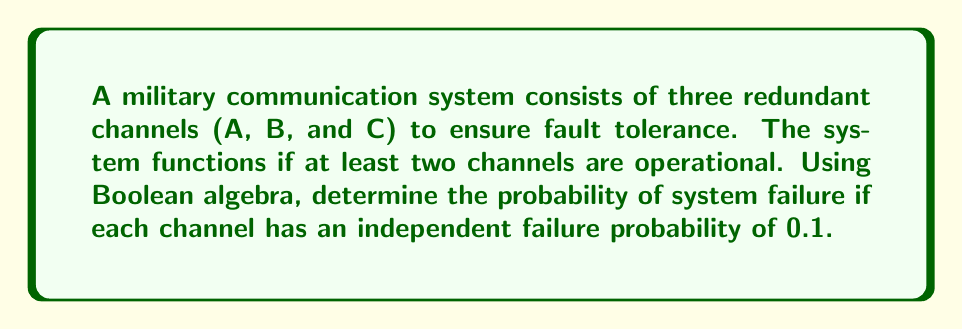Could you help me with this problem? Let's approach this step-by-step using Boolean algebra and probability theory:

1) First, let's define our variables:
   Let A, B, and C represent the event that each channel is operational.

2) The system fails if two or more channels fail. We can express this as:
   System Failure = $\overline{A}\overline{B}\overline{C} + \overline{A}\overline{B}C + \overline{A}B\overline{C} + A\overline{B}\overline{C}$

3) Using De Morgan's law, we can simplify this to:
   System Failure = $\overline{AB + AC + BC}$

4) Now, let's calculate the probability of system success:
   P(System Success) = P(AB + AC + BC)

5) Using the inclusion-exclusion principle:
   P(AB + AC + BC) = P(AB) + P(AC) + P(BC) - P(ABC) - P(AB\overline{C}) - P(A\overline{B}C) - P(\overline{A}BC)

6) Given that each channel has a 0.9 probability of being operational:
   P(AB) = P(AC) = P(BC) = 0.9 * 0.9 = 0.81
   P(ABC) = 0.9 * 0.9 * 0.9 = 0.729
   P(AB\overline{C}) = P(A\overline{B}C) = P(\overline{A}BC) = 0.9 * 0.9 * 0.1 = 0.081

7) Substituting these values:
   P(System Success) = 0.81 + 0.81 + 0.81 - 0.729 - 0.081 - 0.081 - 0.081 = 0.999

8) Therefore, the probability of system failure is:
   P(System Failure) = 1 - P(System Success) = 1 - 0.999 = 0.001
Answer: 0.001 